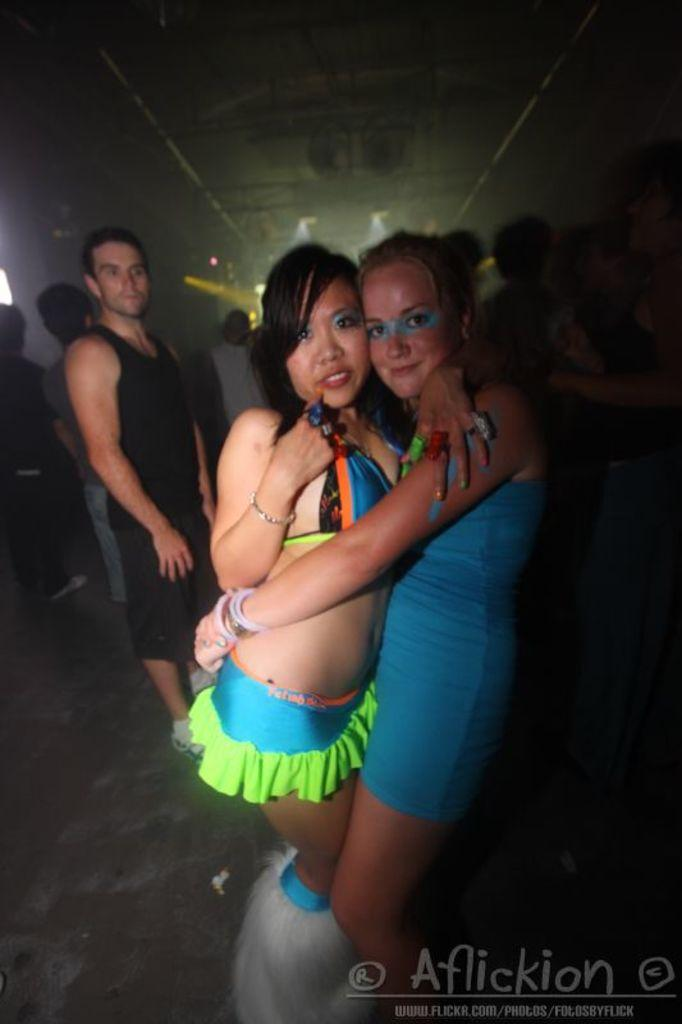What is happening in the foreground of the image? There is a group of people on the floor in the foreground of the image. What can be seen on the floor near the people? There is a logo and text in the foreground of the image. What is visible in the background of the image? There is a wall and lights in the background of the image. What can be inferred about the time of day when the image was taken? The image is likely taken during the night. What can be inferred about the location where the image was taken? The image is likely taken in a hall. How much money is being exchanged between the people in the image? There is no indication of money being exchanged in the image. Why are the people in the image crying? There is no indication of anyone crying in the image. 